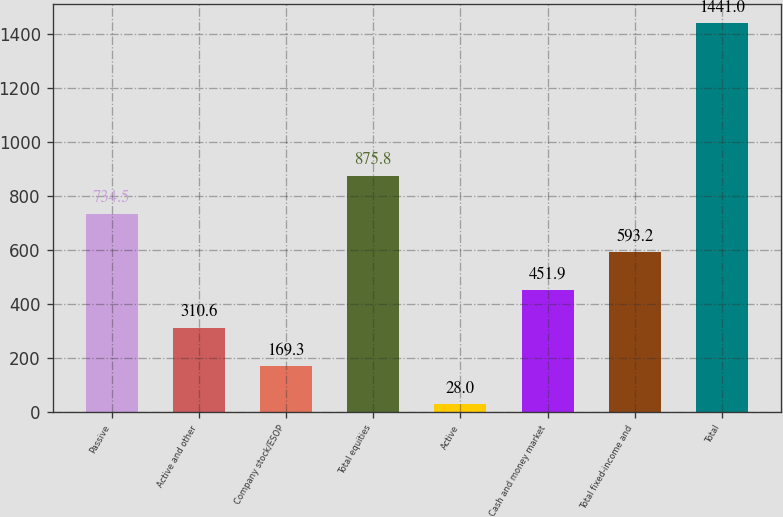Convert chart. <chart><loc_0><loc_0><loc_500><loc_500><bar_chart><fcel>Passive<fcel>Active and other<fcel>Company stock/ESOP<fcel>Total equities<fcel>Active<fcel>Cash and money market<fcel>Total fixed-income and<fcel>Total<nl><fcel>734.5<fcel>310.6<fcel>169.3<fcel>875.8<fcel>28<fcel>451.9<fcel>593.2<fcel>1441<nl></chart> 